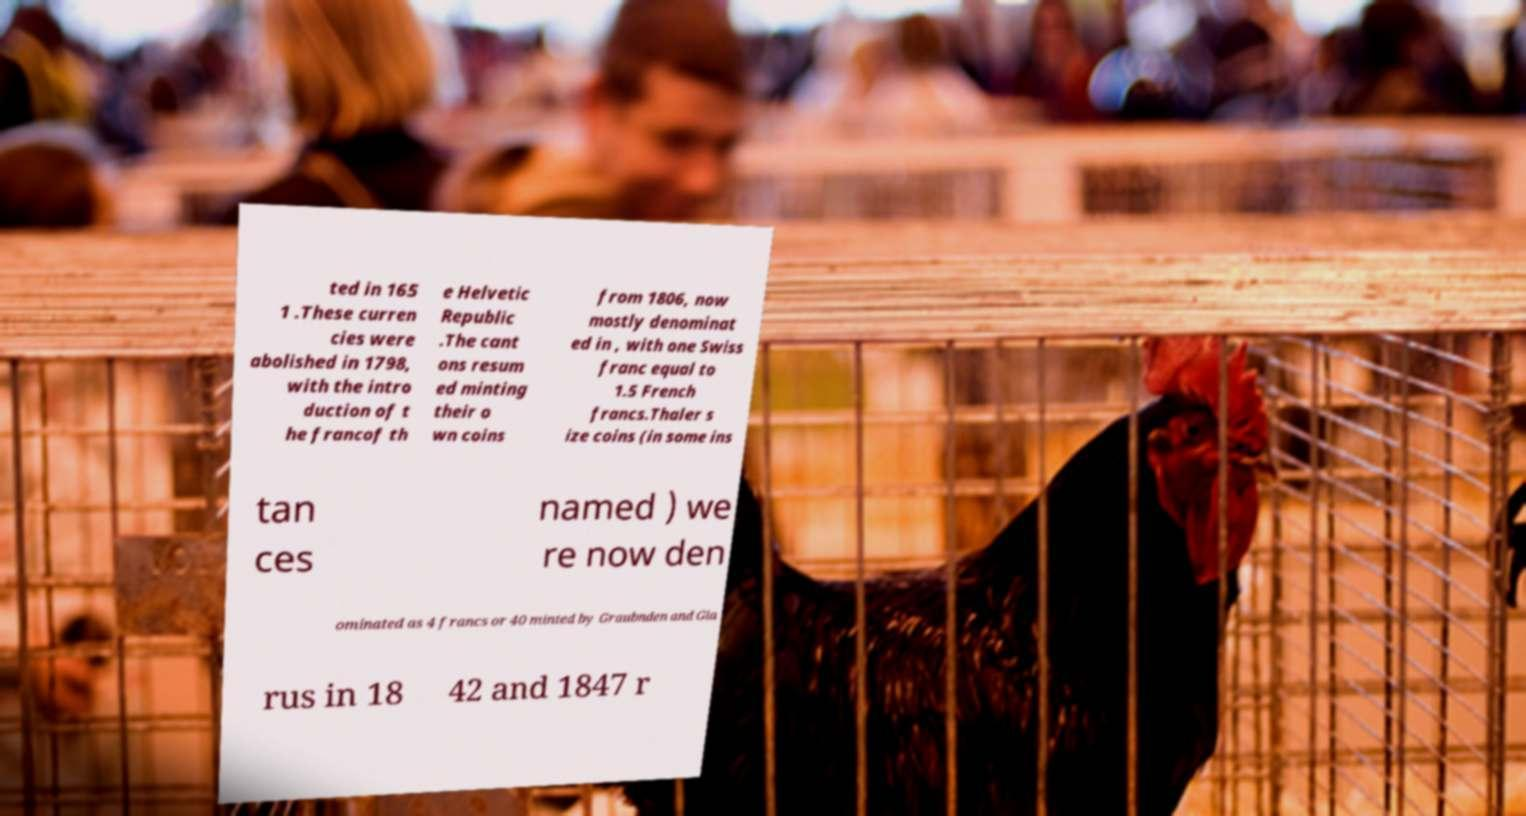Could you extract and type out the text from this image? ted in 165 1 .These curren cies were abolished in 1798, with the intro duction of t he francof th e Helvetic Republic .The cant ons resum ed minting their o wn coins from 1806, now mostly denominat ed in , with one Swiss franc equal to 1.5 French francs.Thaler s ize coins (in some ins tan ces named ) we re now den ominated as 4 francs or 40 minted by Graubnden and Gla rus in 18 42 and 1847 r 